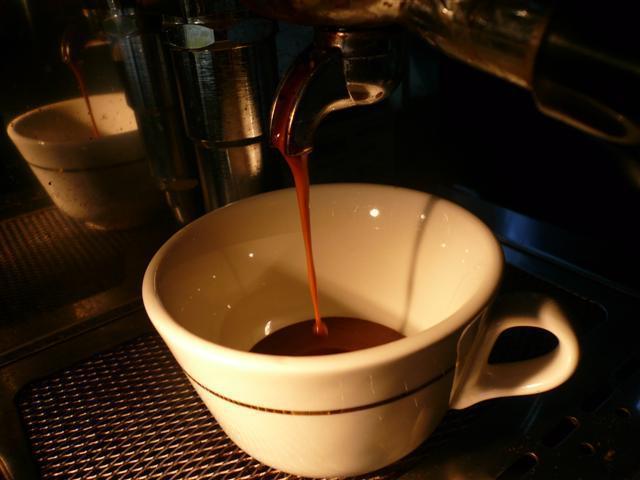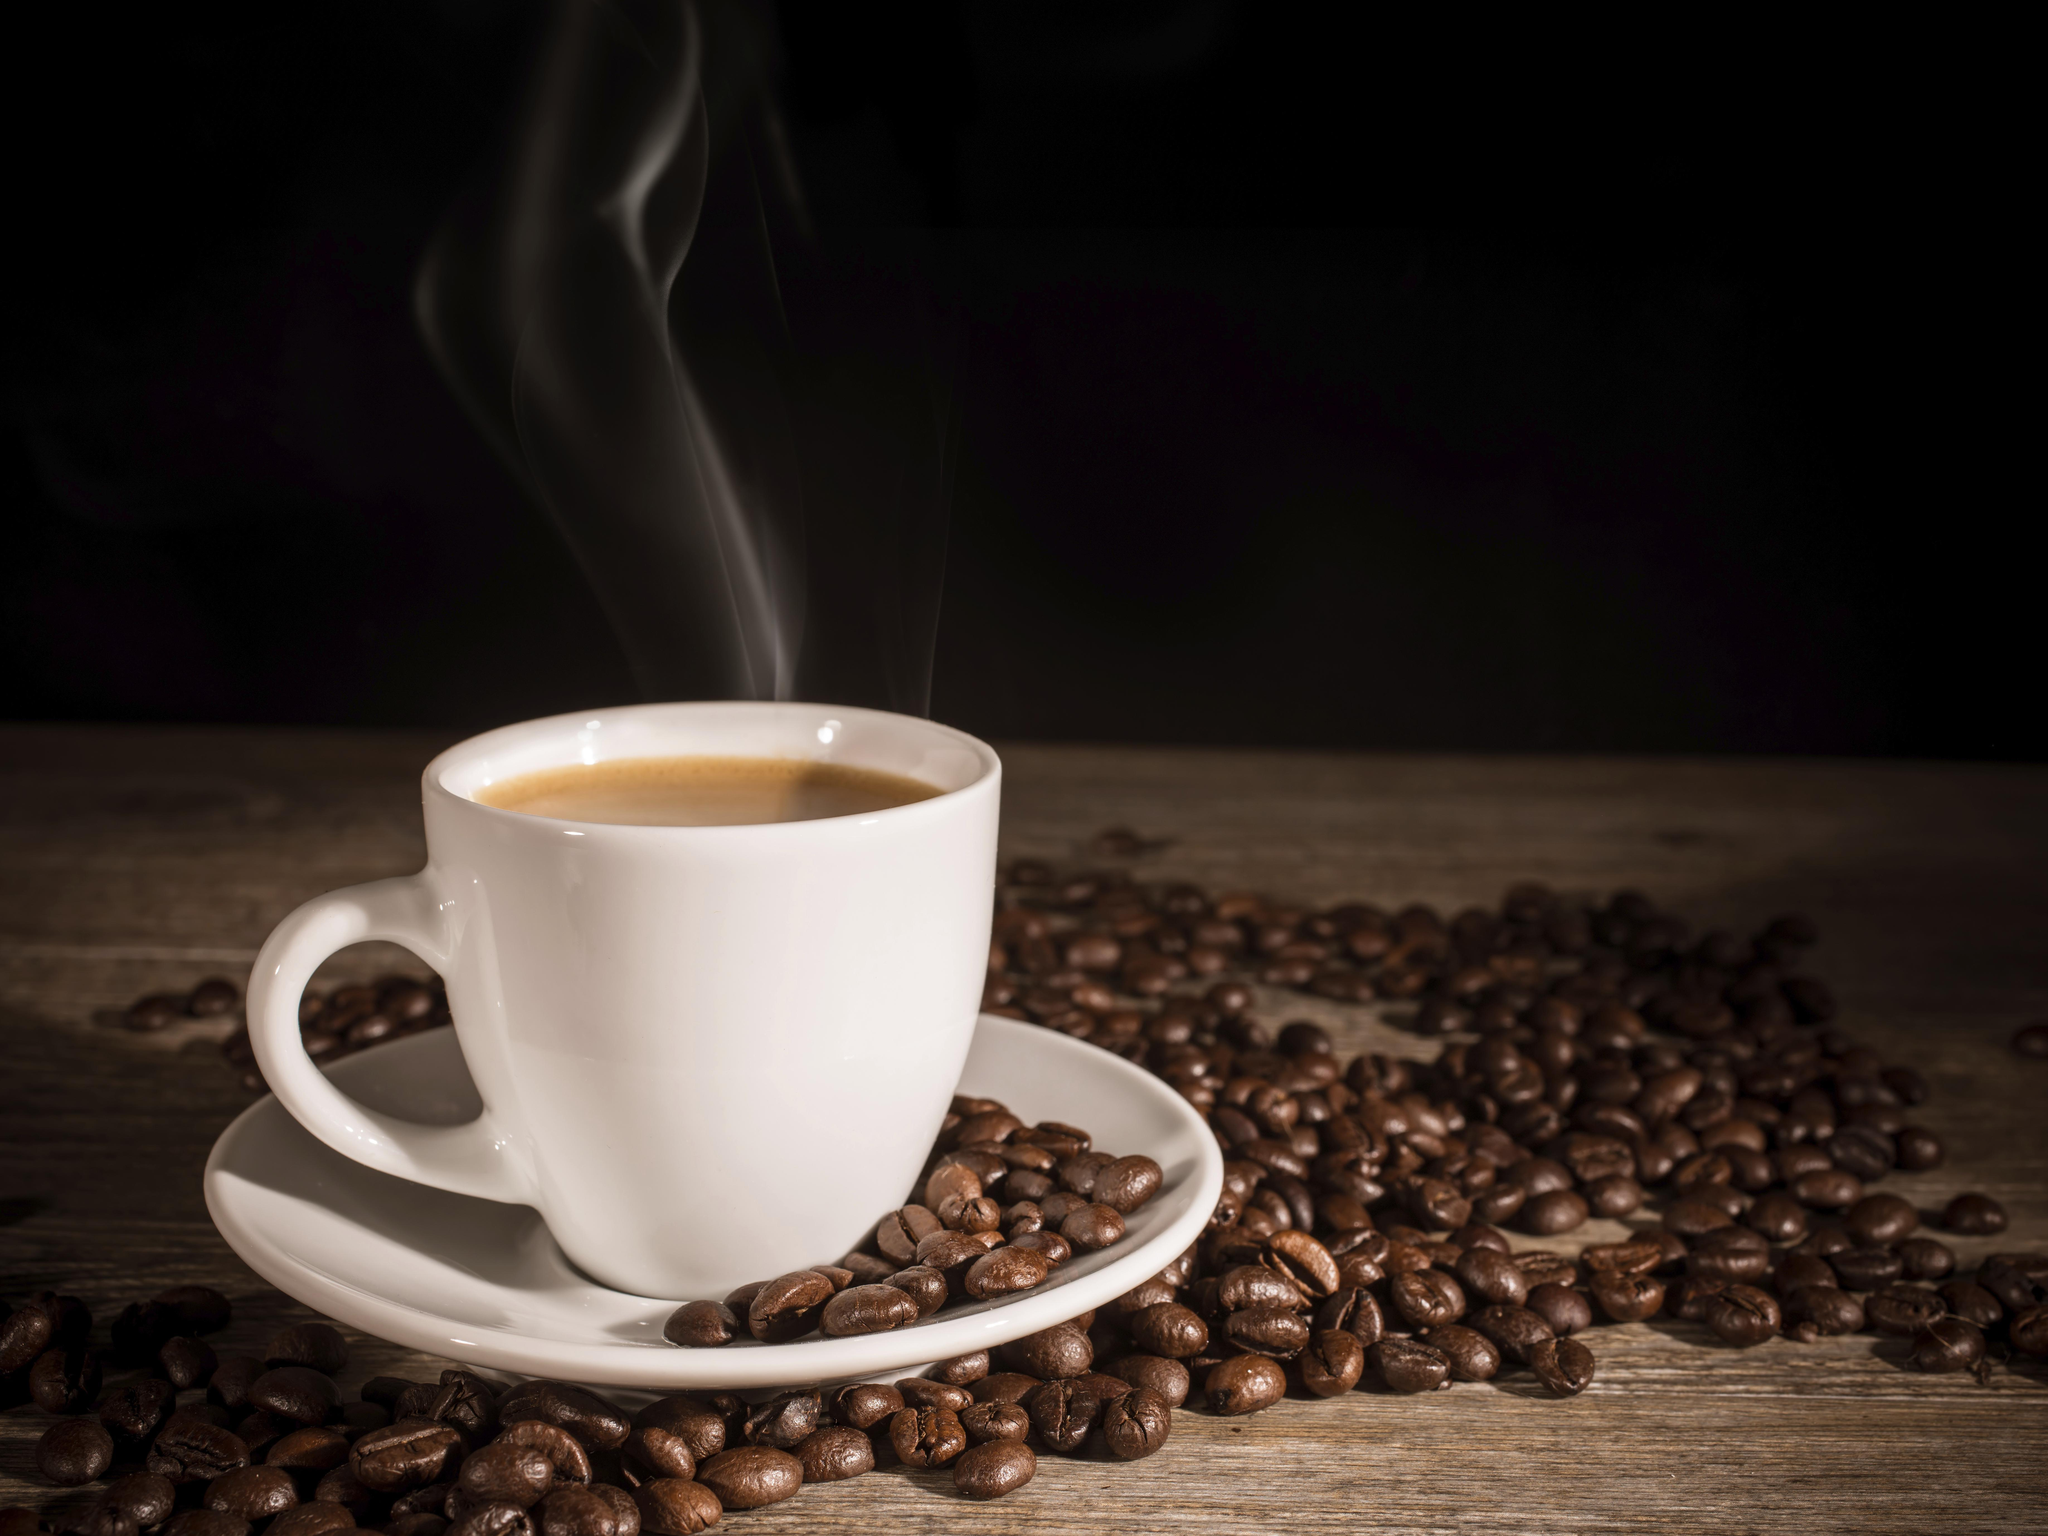The first image is the image on the left, the second image is the image on the right. Given the left and right images, does the statement "There are coffee beans in exactly one of the images." hold true? Answer yes or no. Yes. The first image is the image on the left, the second image is the image on the right. Considering the images on both sides, is "Liquid is being poured into a cup in the left image of the pair." valid? Answer yes or no. Yes. 